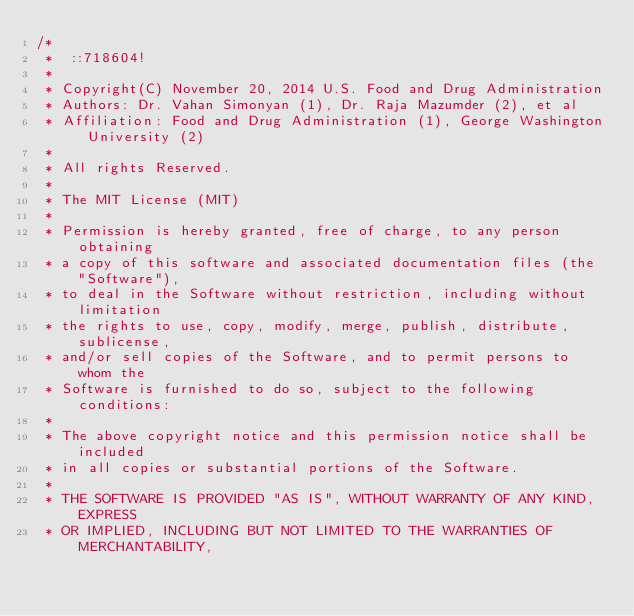Convert code to text. <code><loc_0><loc_0><loc_500><loc_500><_C++_>/*
 *  ::718604!
 * 
 * Copyright(C) November 20, 2014 U.S. Food and Drug Administration
 * Authors: Dr. Vahan Simonyan (1), Dr. Raja Mazumder (2), et al
 * Affiliation: Food and Drug Administration (1), George Washington University (2)
 * 
 * All rights Reserved.
 * 
 * The MIT License (MIT)
 * 
 * Permission is hereby granted, free of charge, to any person obtaining
 * a copy of this software and associated documentation files (the "Software"),
 * to deal in the Software without restriction, including without limitation
 * the rights to use, copy, modify, merge, publish, distribute, sublicense,
 * and/or sell copies of the Software, and to permit persons to whom the
 * Software is furnished to do so, subject to the following conditions:
 * 
 * The above copyright notice and this permission notice shall be included
 * in all copies or substantial portions of the Software.
 * 
 * THE SOFTWARE IS PROVIDED "AS IS", WITHOUT WARRANTY OF ANY KIND, EXPRESS
 * OR IMPLIED, INCLUDING BUT NOT LIMITED TO THE WARRANTIES OF MERCHANTABILITY,</code> 